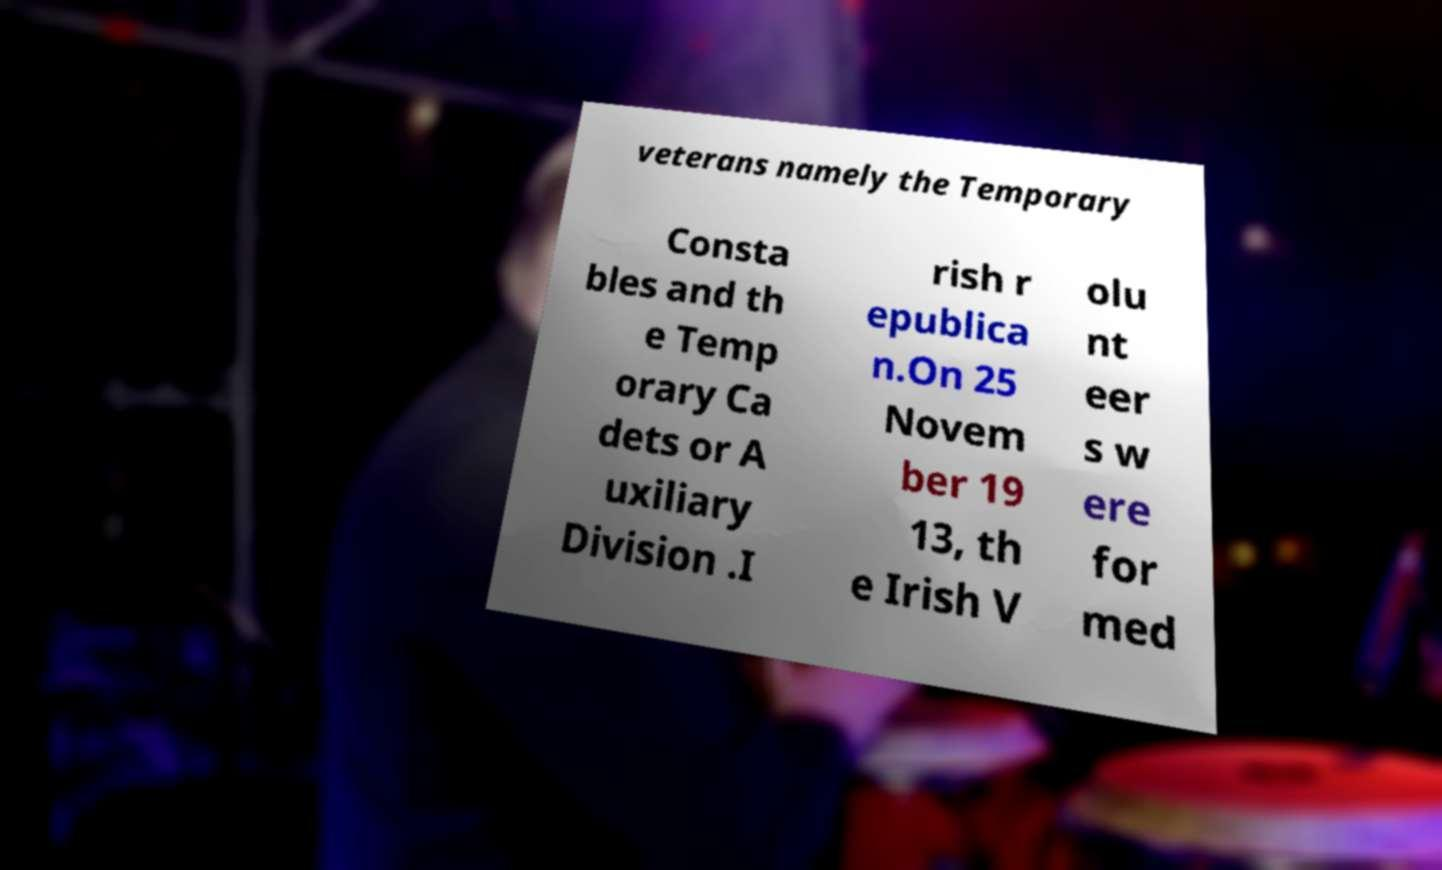Please read and relay the text visible in this image. What does it say? veterans namely the Temporary Consta bles and th e Temp orary Ca dets or A uxiliary Division .I rish r epublica n.On 25 Novem ber 19 13, th e Irish V olu nt eer s w ere for med 